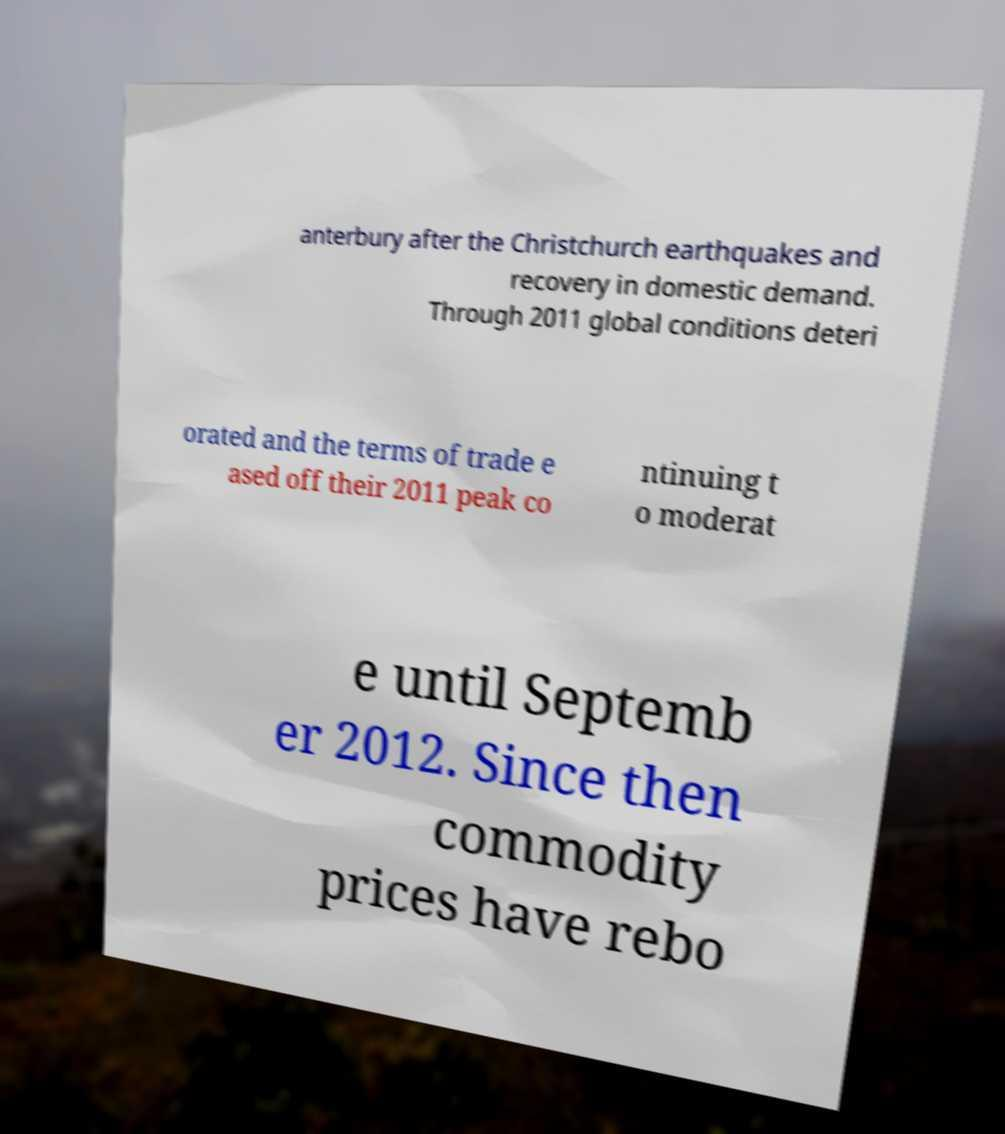For documentation purposes, I need the text within this image transcribed. Could you provide that? anterbury after the Christchurch earthquakes and recovery in domestic demand. Through 2011 global conditions deteri orated and the terms of trade e ased off their 2011 peak co ntinuing t o moderat e until Septemb er 2012. Since then commodity prices have rebo 